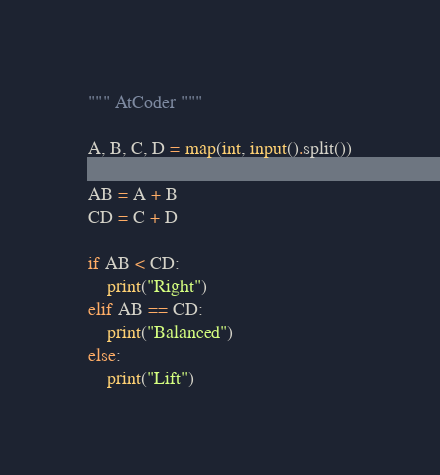Convert code to text. <code><loc_0><loc_0><loc_500><loc_500><_Python_>""" AtCoder """

A, B, C, D = map(int, input().split())

AB = A + B
CD = C + D

if AB < CD:
    print("Right")
elif AB == CD:
    print("Balanced")
else:
    print("Lift")
</code> 